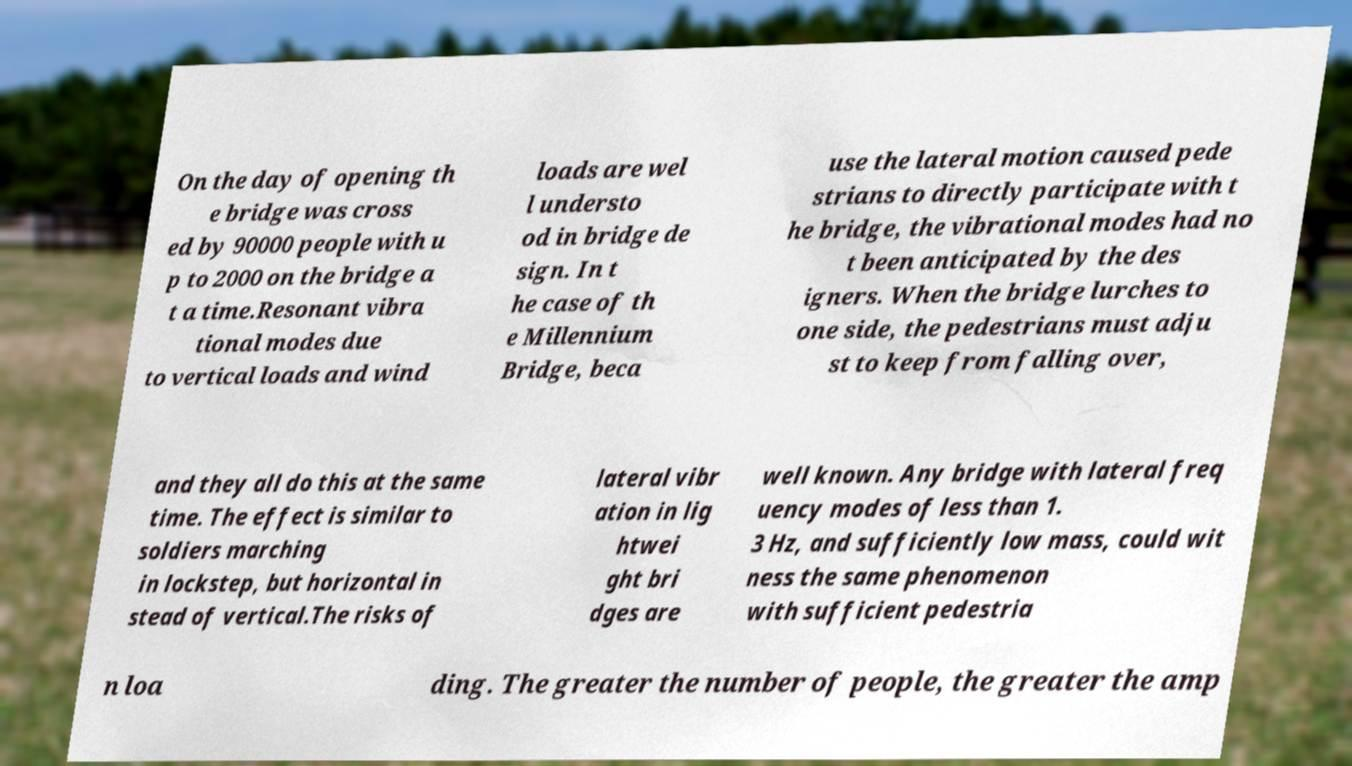Could you assist in decoding the text presented in this image and type it out clearly? On the day of opening th e bridge was cross ed by 90000 people with u p to 2000 on the bridge a t a time.Resonant vibra tional modes due to vertical loads and wind loads are wel l understo od in bridge de sign. In t he case of th e Millennium Bridge, beca use the lateral motion caused pede strians to directly participate with t he bridge, the vibrational modes had no t been anticipated by the des igners. When the bridge lurches to one side, the pedestrians must adju st to keep from falling over, and they all do this at the same time. The effect is similar to soldiers marching in lockstep, but horizontal in stead of vertical.The risks of lateral vibr ation in lig htwei ght bri dges are well known. Any bridge with lateral freq uency modes of less than 1. 3 Hz, and sufficiently low mass, could wit ness the same phenomenon with sufficient pedestria n loa ding. The greater the number of people, the greater the amp 